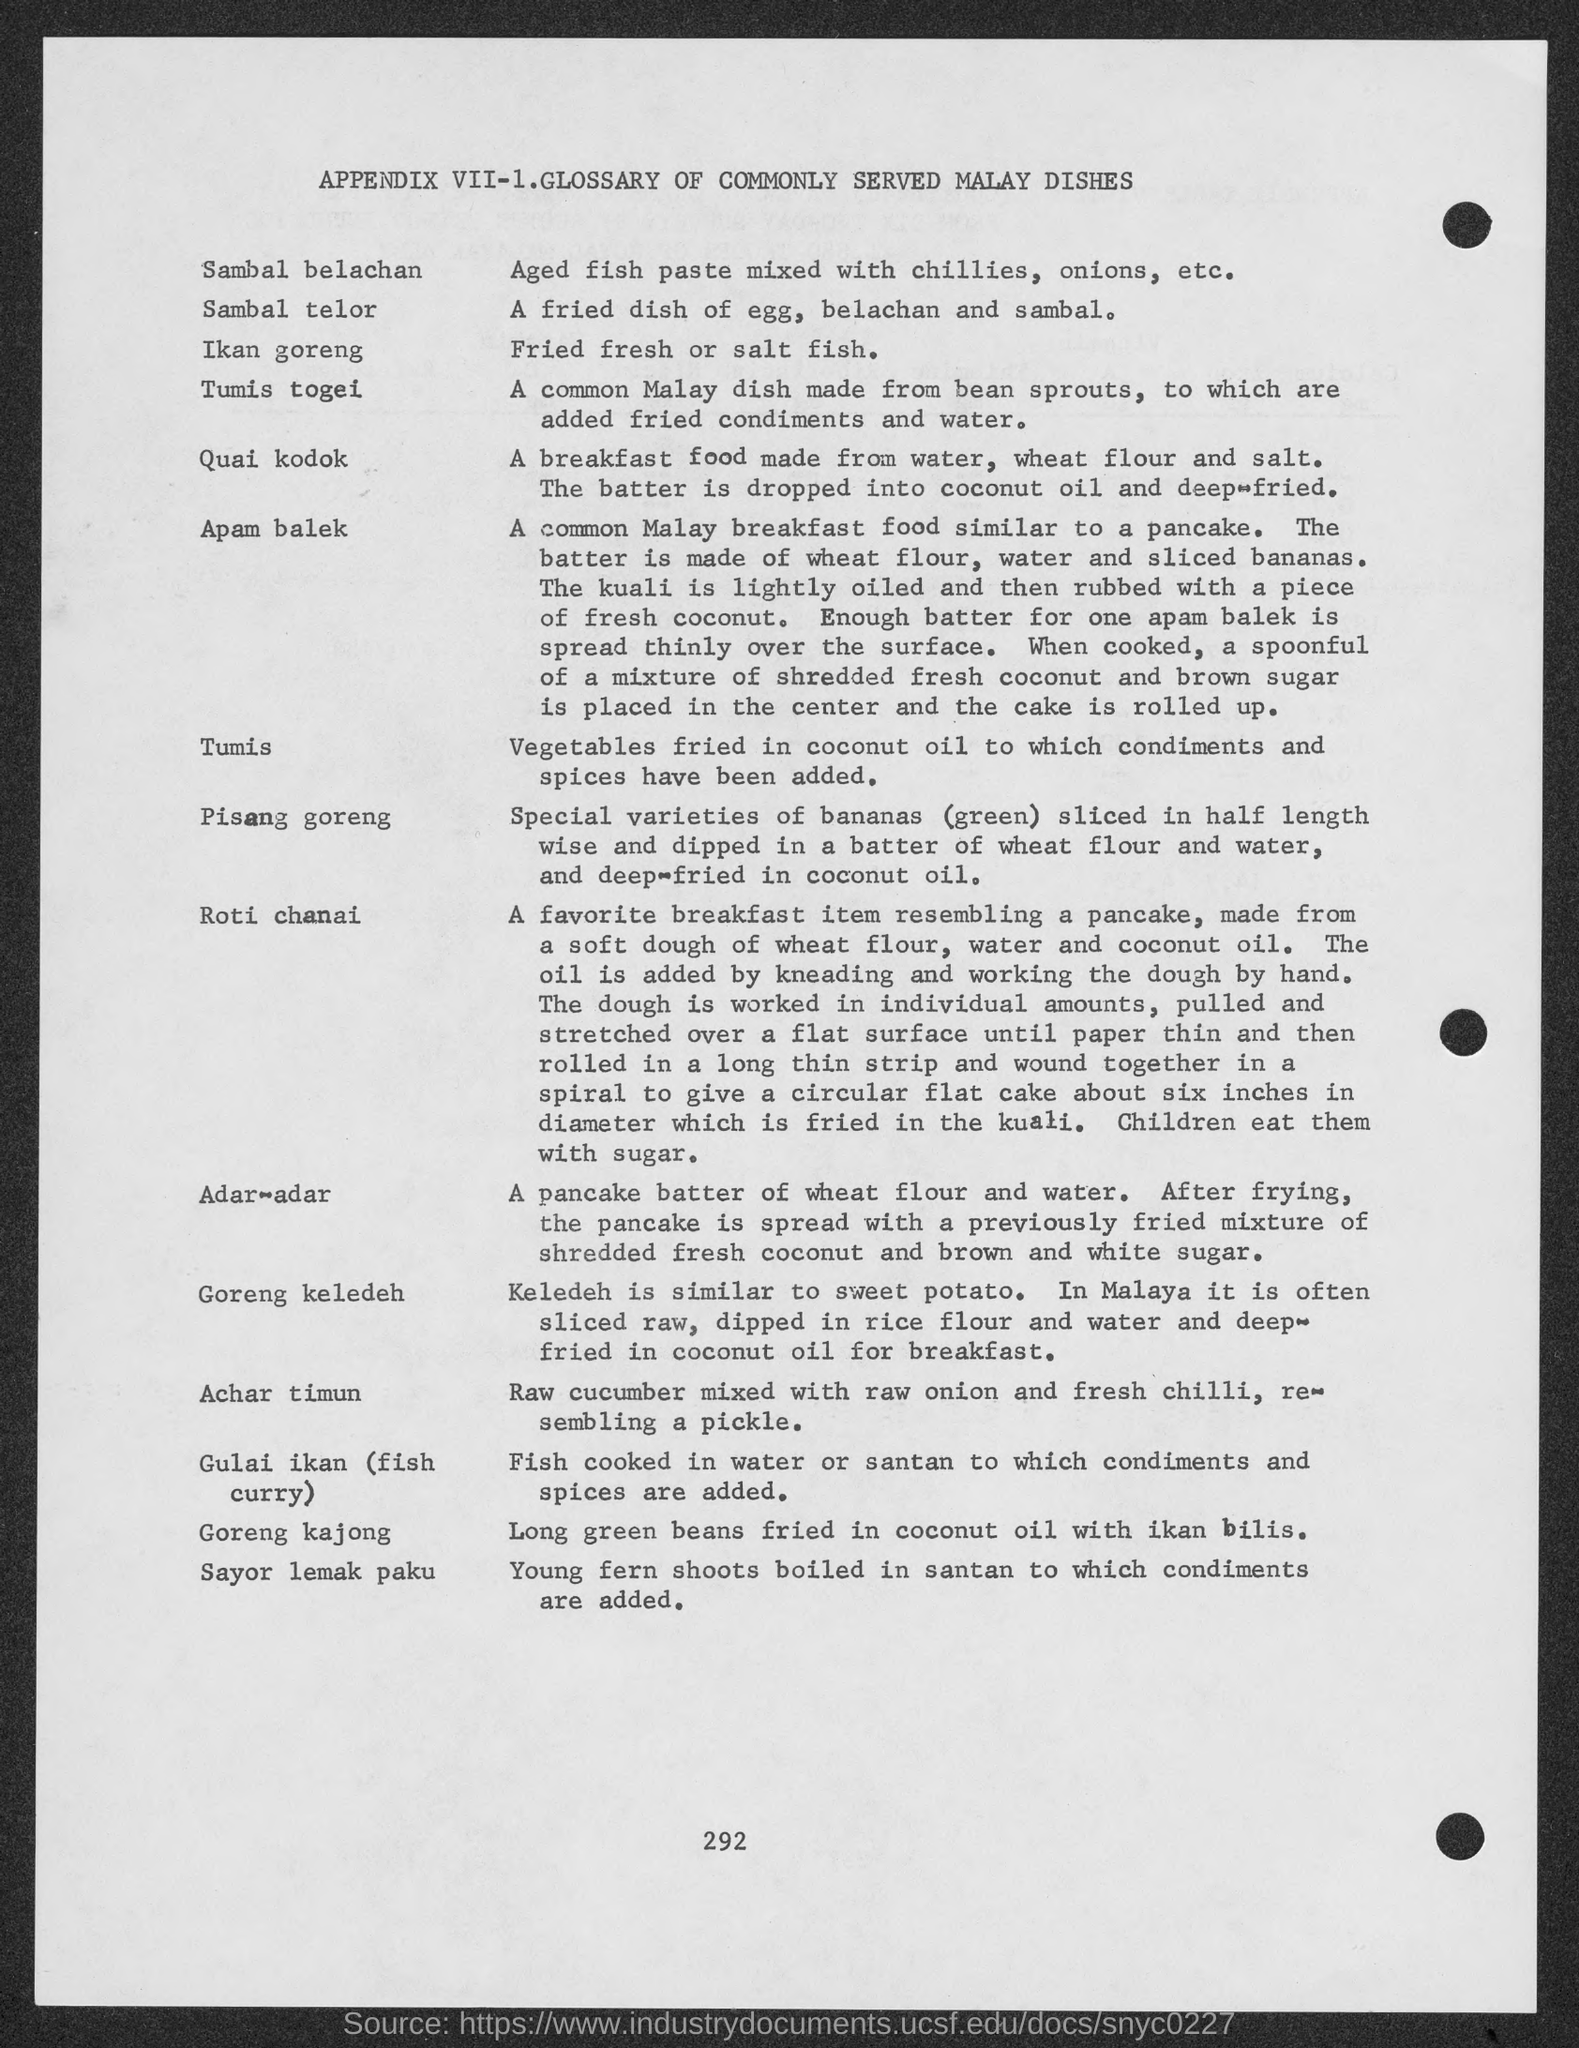What is the fried dish of egg, belachan and sambal?
Ensure brevity in your answer.  Sambal Telor. What is the aged fish paste mixed with chillies, onions, etc.?
Offer a terse response. Sambal Belachan. 